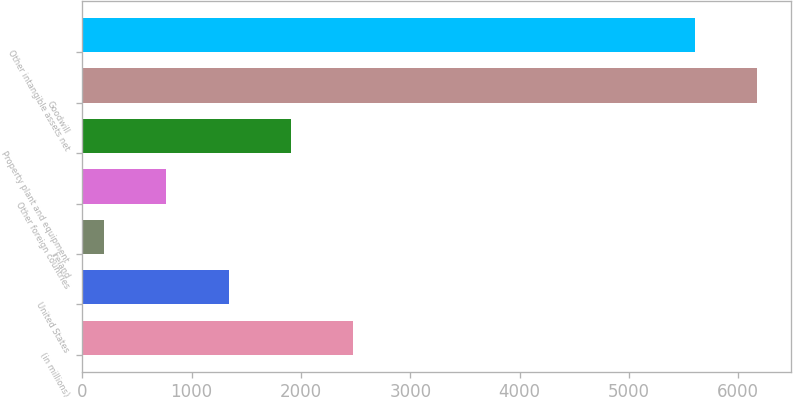Convert chart. <chart><loc_0><loc_0><loc_500><loc_500><bar_chart><fcel>(in millions)<fcel>United States<fcel>Ireland<fcel>Other foreign countries<fcel>Property plant and equipment<fcel>Goodwill<fcel>Other intangible assets net<nl><fcel>2477.4<fcel>1337.2<fcel>197<fcel>767.1<fcel>1907.3<fcel>6176.1<fcel>5606<nl></chart> 